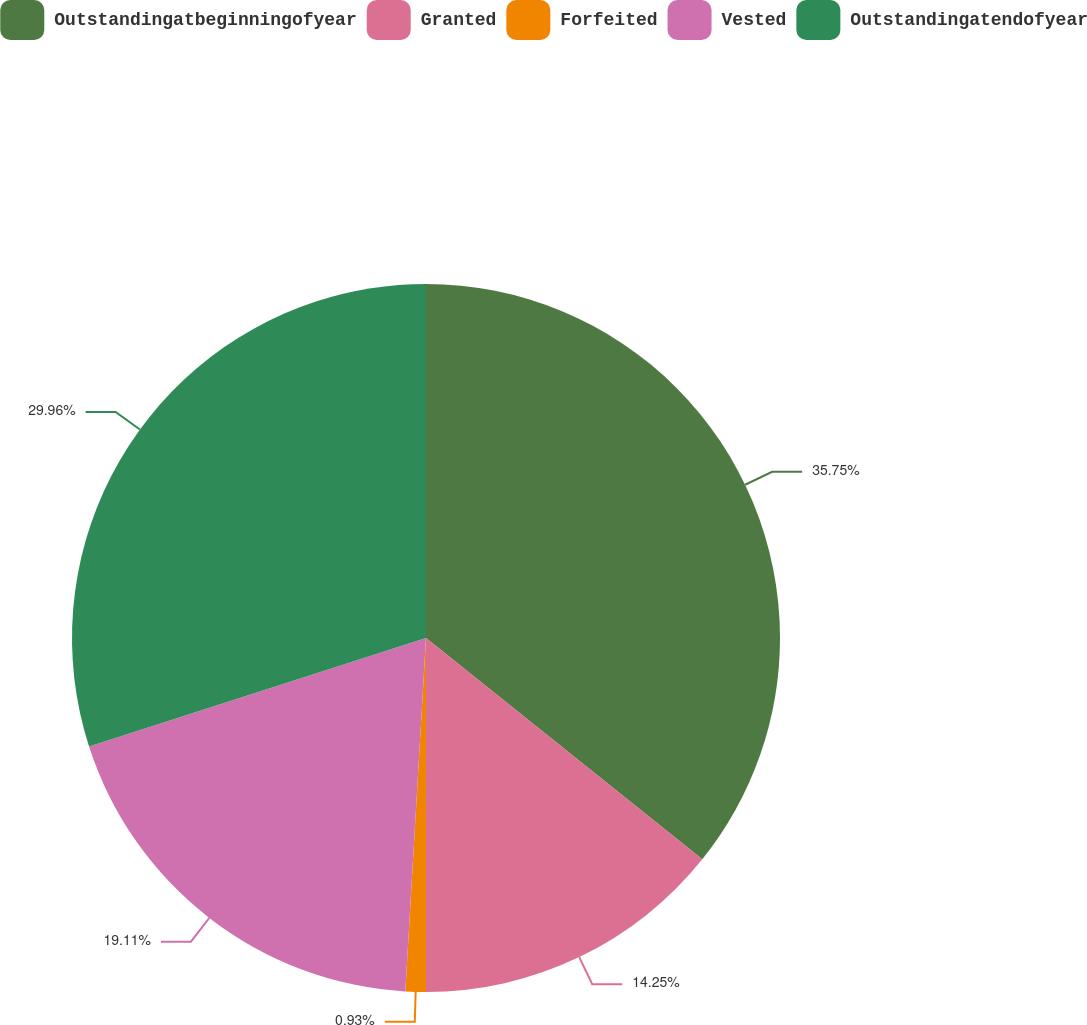Convert chart to OTSL. <chart><loc_0><loc_0><loc_500><loc_500><pie_chart><fcel>Outstandingatbeginningofyear<fcel>Granted<fcel>Forfeited<fcel>Vested<fcel>Outstandingatendofyear<nl><fcel>35.75%<fcel>14.25%<fcel>0.93%<fcel>19.11%<fcel>29.96%<nl></chart> 